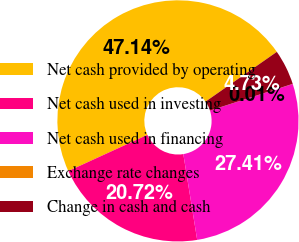Convert chart to OTSL. <chart><loc_0><loc_0><loc_500><loc_500><pie_chart><fcel>Net cash provided by operating<fcel>Net cash used in investing<fcel>Net cash used in financing<fcel>Exchange rate changes<fcel>Change in cash and cash<nl><fcel>47.14%<fcel>20.72%<fcel>27.41%<fcel>0.01%<fcel>4.73%<nl></chart> 